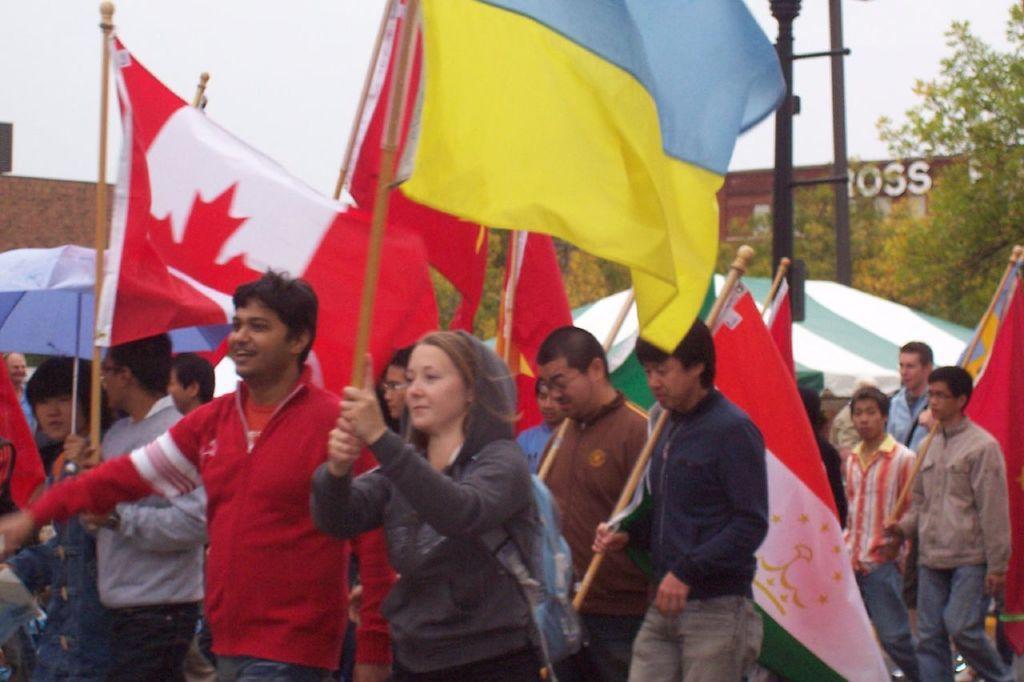Could you give a brief overview of what you see in this image? As we can see in the image there are few people here and there and holding flags. In the background there are trees and house. On the top there is sky. 